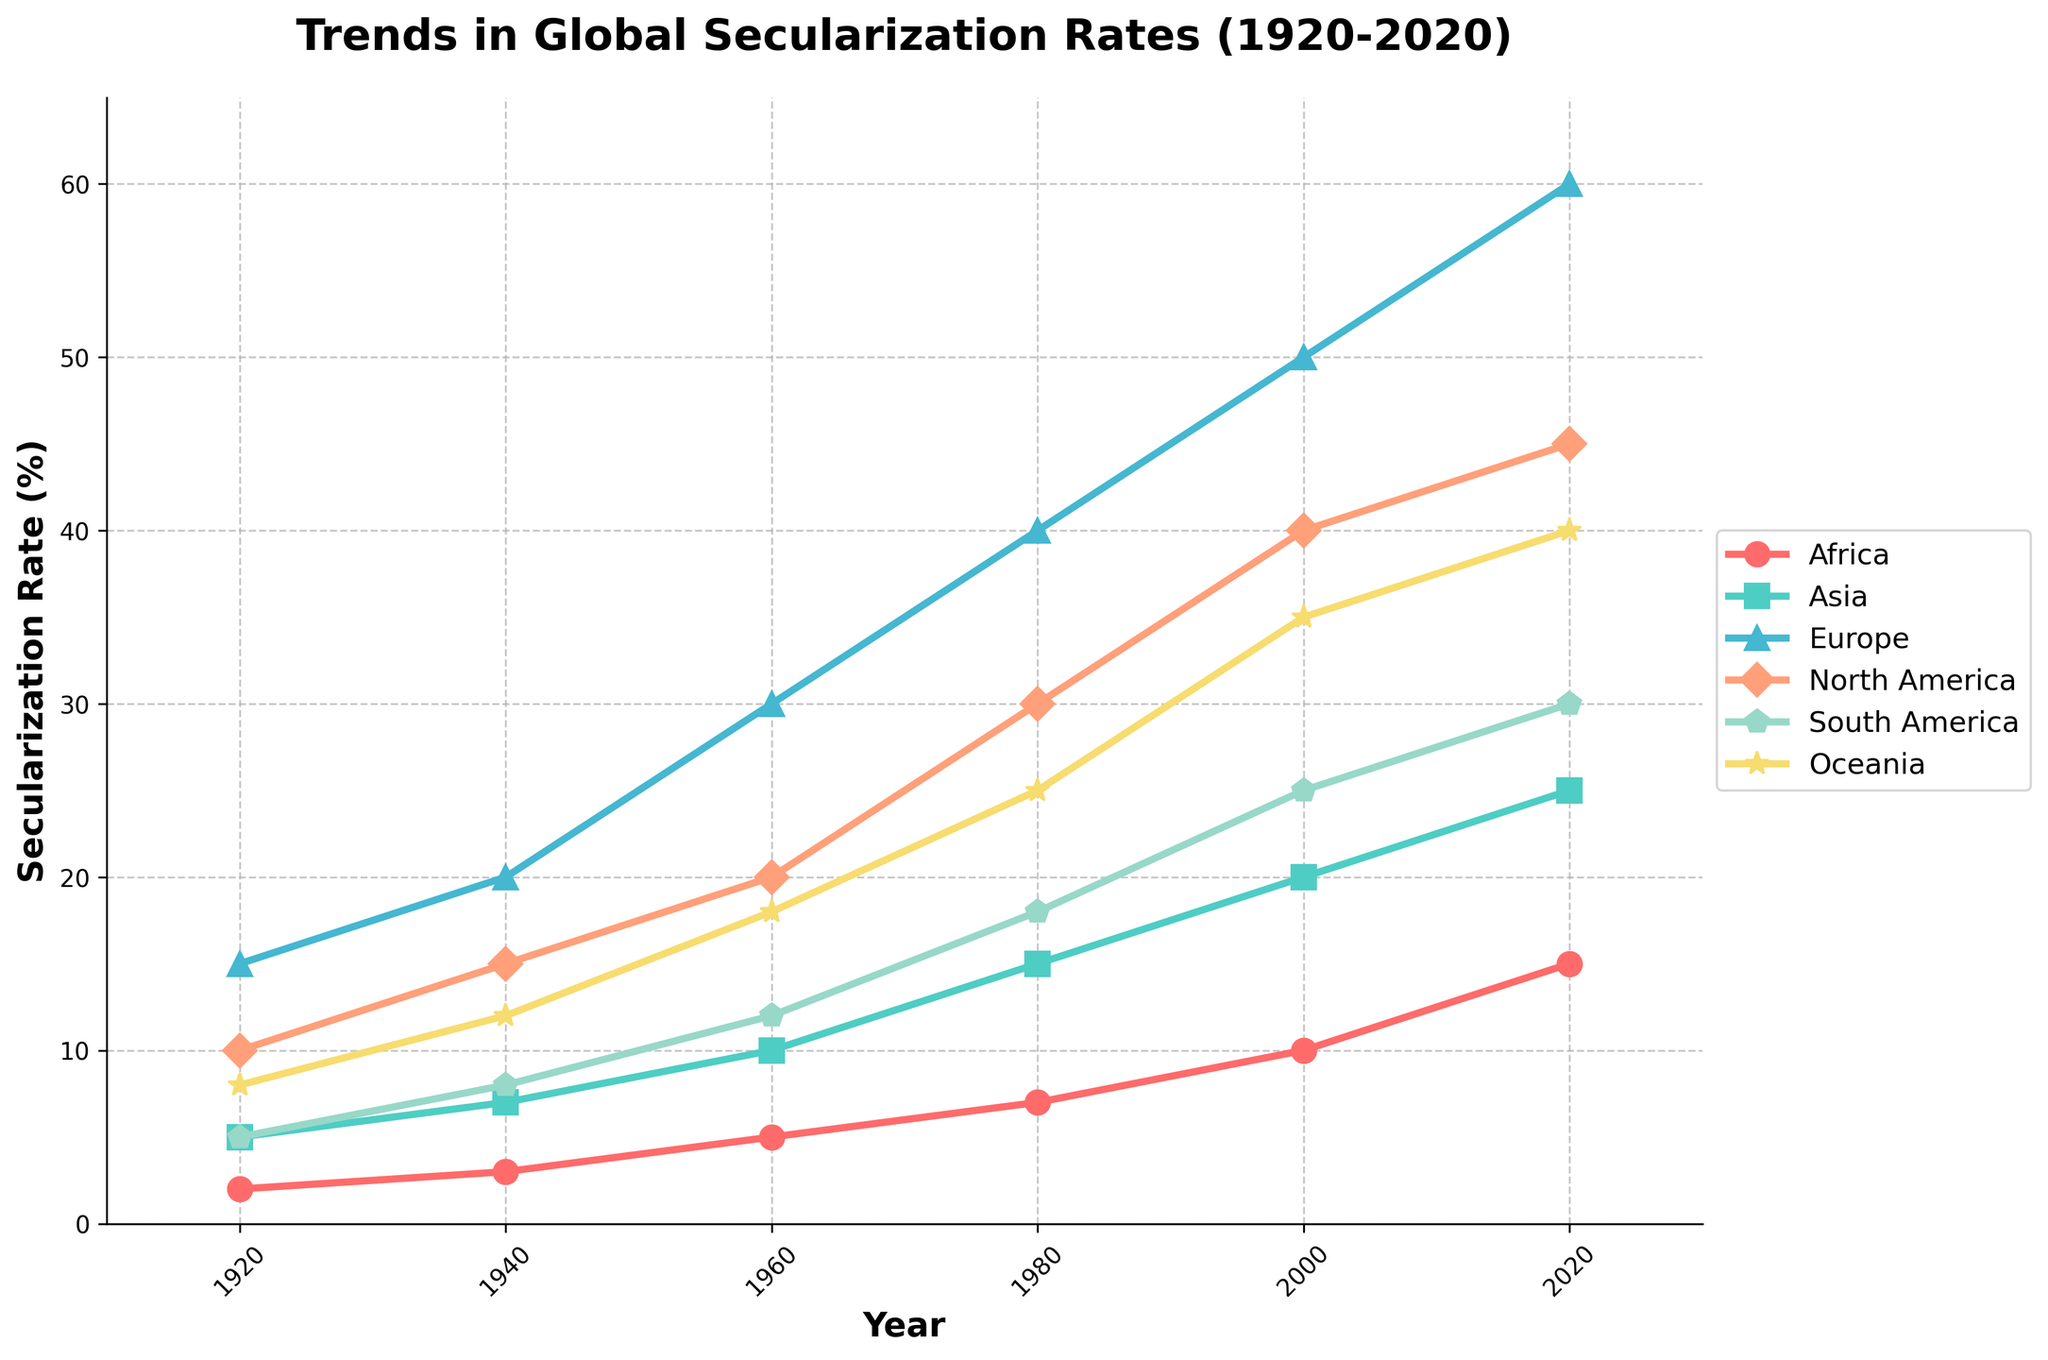Which continent had the most significant increase in secularization rates between 1920 and 2020? To determine the most significant increase, we subtract the 1920 values from the 2020 values for each continent: Africa (15 - 2 = 13), Asia (25 - 5 = 20), Europe (60 - 15 = 45), North America (45 - 10 = 35), South America (30 - 5 = 25), and Oceania (40 - 8 = 32). Europe has the highest increase.
Answer: Europe In 1980, which two continents had almost the same secularization rates? Checking the 1980 data, Africa (7%), Asia (15%), Europe (40%), North America (30%), South America (18%), and Oceania (25%). South America (18%) and Oceania (25%) had closer rates compared to others.
Answer: South America and Oceania What is the difference in secularization rates between North America and Europe in 2020? The data for 2020 shows North America (45%) and Europe (60%). The difference is 60% - 45% = 15%.
Answer: 15% Which continent had the lowest secularization rate in 1940? By looking at the 1940 data, Africa (3%), Asia (7%), Europe (20%), North America (15%), South America (8%), and Oceania (12%). Africa had the lowest secularization rate.
Answer: Africa If we calculate the average secularization rate for all continents in 2000, what would it be? The values for 2000 are Africa (10%), Asia (20%), Europe (50%), North America (40%), South America (25%), and Oceania (35%). The average is (10 + 20 + 50 + 40 + 25 + 35)/6 ≈ 30%.
Answer: 30% Comparing North America and Oceania, which continent saw a higher relative growth in secularization rates from 1920 to 2020? North America's growth: (45 - 10)/10 = 3.5 (350%). Oceania's growth: (40 - 8)/8 = 4 (400%). Oceania saw higher relative growth.
Answer: Oceania What is the trend in secularization rates in Africa from 1920 to 2020? By examining Africa's data points (2%, 3%, 5%, 7%, 10%, 15%), we observe a consistent increase over the century.
Answer: Consistent increase 